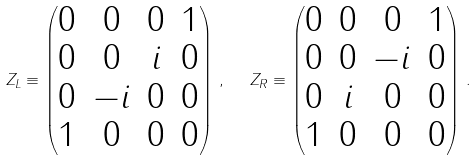Convert formula to latex. <formula><loc_0><loc_0><loc_500><loc_500>Z _ { L } \equiv \begin{pmatrix} 0 & 0 & 0 & 1 \\ 0 & 0 & i & 0 \\ 0 & - i & 0 & 0 \\ 1 & 0 & 0 & 0 \end{pmatrix} \, , \ \ Z _ { R } \equiv \begin{pmatrix} 0 & 0 & 0 & 1 \\ 0 & 0 & - i & 0 \\ 0 & i & 0 & 0 \\ 1 & 0 & 0 & 0 \end{pmatrix} \, .</formula> 